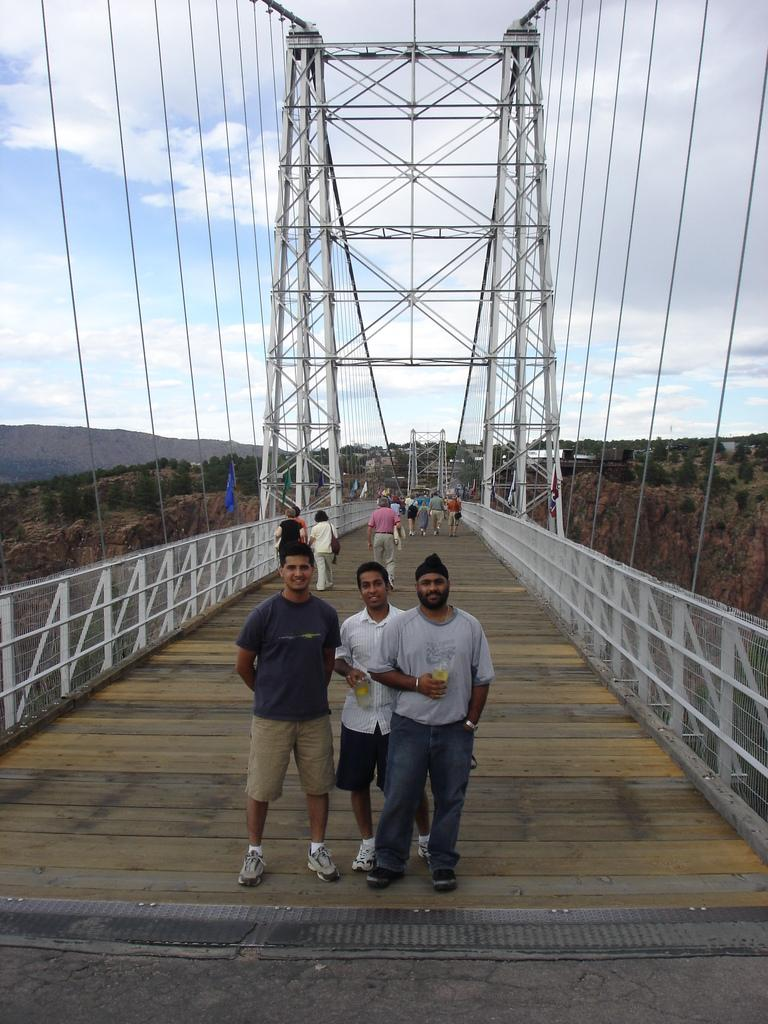What are the people in the foreground of the image doing? The people in the foreground of the image are standing on a bridge. What can be seen in the background of the image? In the background of the image, there are people, trees, ropes, mountains, and the sky. What type of natural feature is visible in the background of the image? Mountains are visible in the background of the image. What is the condition of the sky in the image? The sky is visible in the background of the image. Can you see any planes flying through the mist in the image? There is no mist or planes present in the image. What type of smoke is coming from the trees in the background of the image? There is no smoke coming from the trees in the image; only trees, ropes, mountains, and the sky are visible in the background. 